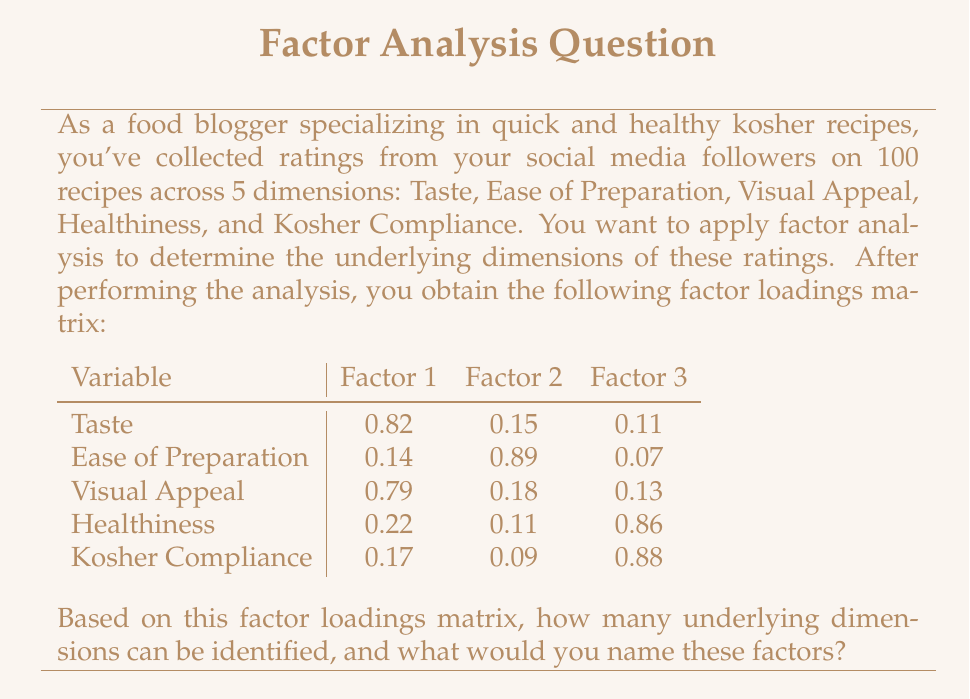Teach me how to tackle this problem. To determine the underlying dimensions from the factor analysis results, we need to examine the factor loadings matrix and interpret the patterns. Let's go through this step-by-step:

1. Examine the factor loadings:
   - Factor loadings greater than 0.5 are typically considered significant.
   - We look for variables that load highly on one factor and low on others.

2. Analyze each factor:
   - Factor 1: High loadings for Taste (0.82) and Visual Appeal (0.79)
   - Factor 2: High loading for Ease of Preparation (0.89)
   - Factor 3: High loadings for Healthiness (0.86) and Kosher Compliance (0.88)

3. Interpret the factors:
   - Factor 1 combines Taste and Visual Appeal, which could be named "Sensory Appeal"
   - Factor 2 is primarily about Ease of Preparation, so it could be named "Convenience"
   - Factor 3 combines Healthiness and Kosher Compliance, which could be named "Dietary Adherence"

4. Count the number of factors:
   There are 3 distinct factors identified in this analysis.

5. Name the factors based on their components:
   - Factor 1: Sensory Appeal
   - Factor 2: Convenience
   - Factor 3: Dietary Adherence

Therefore, the factor analysis reveals 3 underlying dimensions that can be meaningfully named based on the variables they represent.
Answer: 3 factors: Sensory Appeal, Convenience, and Dietary Adherence 